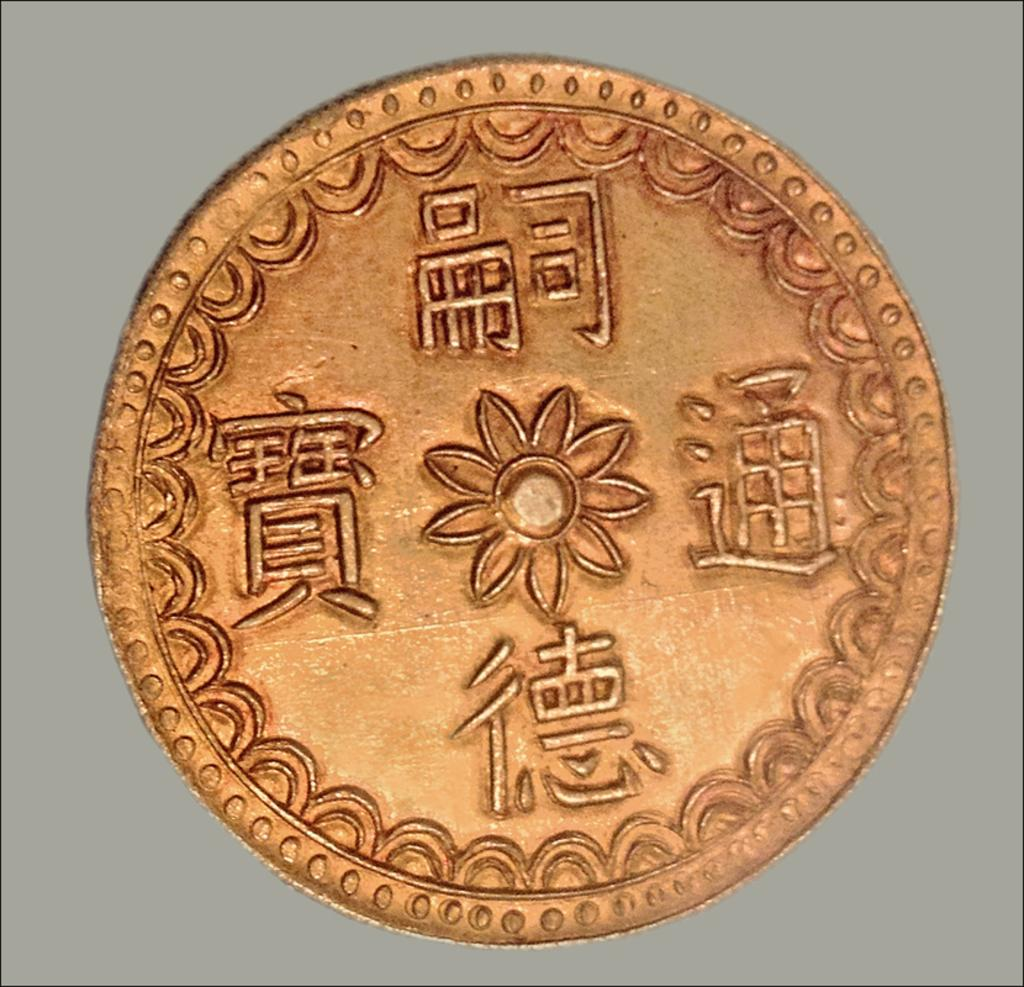What object is the main focus of the image? There is a coin in the image. What can be seen behind the coin? The background of the image is plain. How many legs can be seen on the person in the image? There is no person present in the image, only a coin. What type of sorting method is being used in the image? There is no sorting method present in the image, only a coin. 